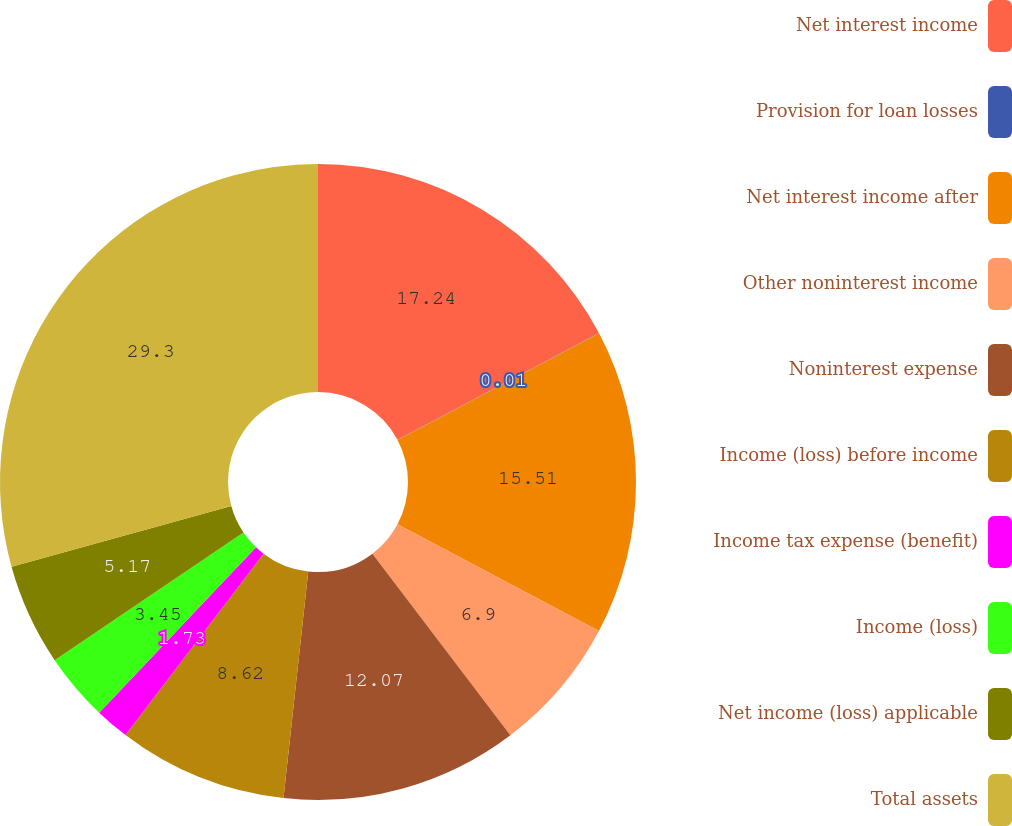<chart> <loc_0><loc_0><loc_500><loc_500><pie_chart><fcel>Net interest income<fcel>Provision for loan losses<fcel>Net interest income after<fcel>Other noninterest income<fcel>Noninterest expense<fcel>Income (loss) before income<fcel>Income tax expense (benefit)<fcel>Income (loss)<fcel>Net income (loss) applicable<fcel>Total assets<nl><fcel>17.24%<fcel>0.01%<fcel>15.51%<fcel>6.9%<fcel>12.07%<fcel>8.62%<fcel>1.73%<fcel>3.45%<fcel>5.17%<fcel>29.3%<nl></chart> 